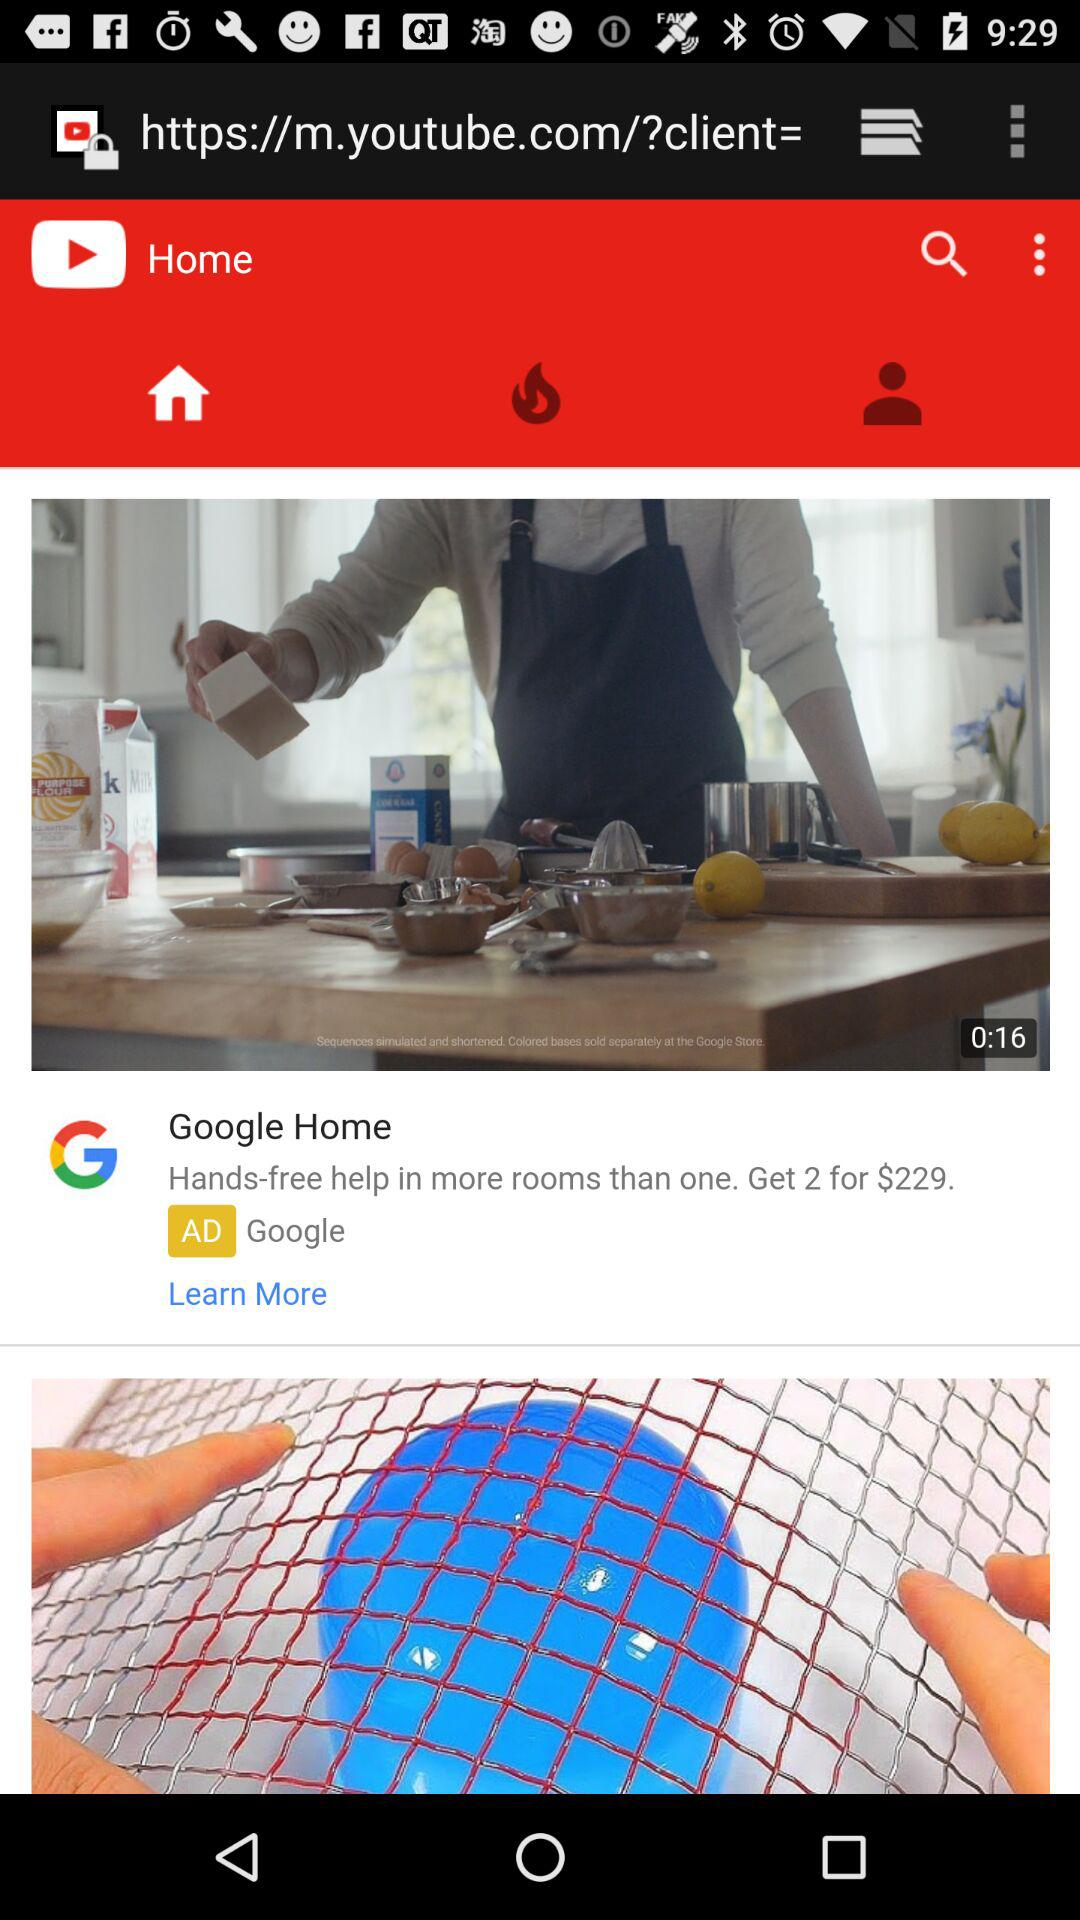What is the duration of the video? The duration of the video is 16 seconds. 